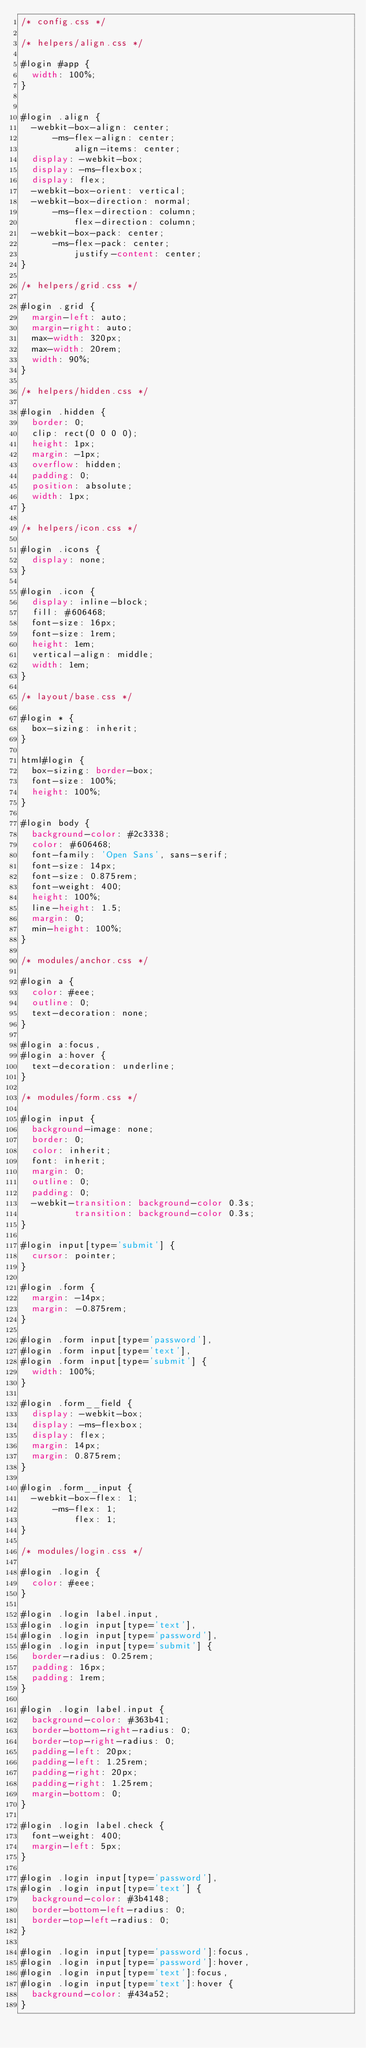Convert code to text. <code><loc_0><loc_0><loc_500><loc_500><_CSS_>/* config.css */

/* helpers/align.css */

#login #app {
  width: 100%;
}


#login .align {
  -webkit-box-align: center;
      -ms-flex-align: center;
          align-items: center;
  display: -webkit-box;
  display: -ms-flexbox;
  display: flex;
  -webkit-box-orient: vertical;
  -webkit-box-direction: normal;
      -ms-flex-direction: column;
          flex-direction: column;
  -webkit-box-pack: center;
      -ms-flex-pack: center;
          justify-content: center;
}

/* helpers/grid.css */

#login .grid {
  margin-left: auto;
  margin-right: auto;
  max-width: 320px;
  max-width: 20rem;
  width: 90%;
}

/* helpers/hidden.css */

#login .hidden {
  border: 0;
  clip: rect(0 0 0 0);
  height: 1px;
  margin: -1px;
  overflow: hidden;
  padding: 0;
  position: absolute;
  width: 1px;
}

/* helpers/icon.css */

#login .icons {
  display: none;
}

#login .icon {
  display: inline-block;
  fill: #606468;
  font-size: 16px;
  font-size: 1rem;
  height: 1em;
  vertical-align: middle;
  width: 1em;
}

/* layout/base.css */

#login * {
  box-sizing: inherit;
}

html#login {
  box-sizing: border-box;
  font-size: 100%;
  height: 100%;
}

#login body {
  background-color: #2c3338;
  color: #606468;
  font-family: 'Open Sans', sans-serif;
  font-size: 14px;
  font-size: 0.875rem;
  font-weight: 400;
  height: 100%;
  line-height: 1.5;
  margin: 0;
  min-height: 100%;
}

/* modules/anchor.css */

#login a {
  color: #eee;
  outline: 0;
  text-decoration: none;
}

#login a:focus,
#login a:hover {
  text-decoration: underline;
}

/* modules/form.css */

#login input {
  background-image: none;
  border: 0;
  color: inherit;
  font: inherit;
  margin: 0;
  outline: 0;
  padding: 0;
  -webkit-transition: background-color 0.3s;
          transition: background-color 0.3s;
}

#login input[type='submit'] {
  cursor: pointer;
}

#login .form {
  margin: -14px;
  margin: -0.875rem;
}

#login .form input[type='password'],
#login .form input[type='text'],
#login .form input[type='submit'] {
  width: 100%;
}

#login .form__field {
  display: -webkit-box;
  display: -ms-flexbox;
  display: flex;
  margin: 14px;
  margin: 0.875rem;
}

#login .form__input {
  -webkit-box-flex: 1;
      -ms-flex: 1;
          flex: 1;
}

/* modules/login.css */

#login .login {
  color: #eee;
}

#login .login label.input,
#login .login input[type='text'],
#login .login input[type='password'],
#login .login input[type='submit'] {
  border-radius: 0.25rem;
  padding: 16px;
  padding: 1rem;
}

#login .login label.input {
  background-color: #363b41;
  border-bottom-right-radius: 0;
  border-top-right-radius: 0;
  padding-left: 20px;
  padding-left: 1.25rem;
  padding-right: 20px;
  padding-right: 1.25rem;
  margin-bottom: 0;
}

#login .login label.check {
  font-weight: 400;
  margin-left: 5px;
}

#login .login input[type='password'],
#login .login input[type='text'] {
  background-color: #3b4148;
  border-bottom-left-radius: 0;
  border-top-left-radius: 0;
}

#login .login input[type='password']:focus,
#login .login input[type='password']:hover,
#login .login input[type='text']:focus,
#login .login input[type='text']:hover {
  background-color: #434a52;
}
</code> 